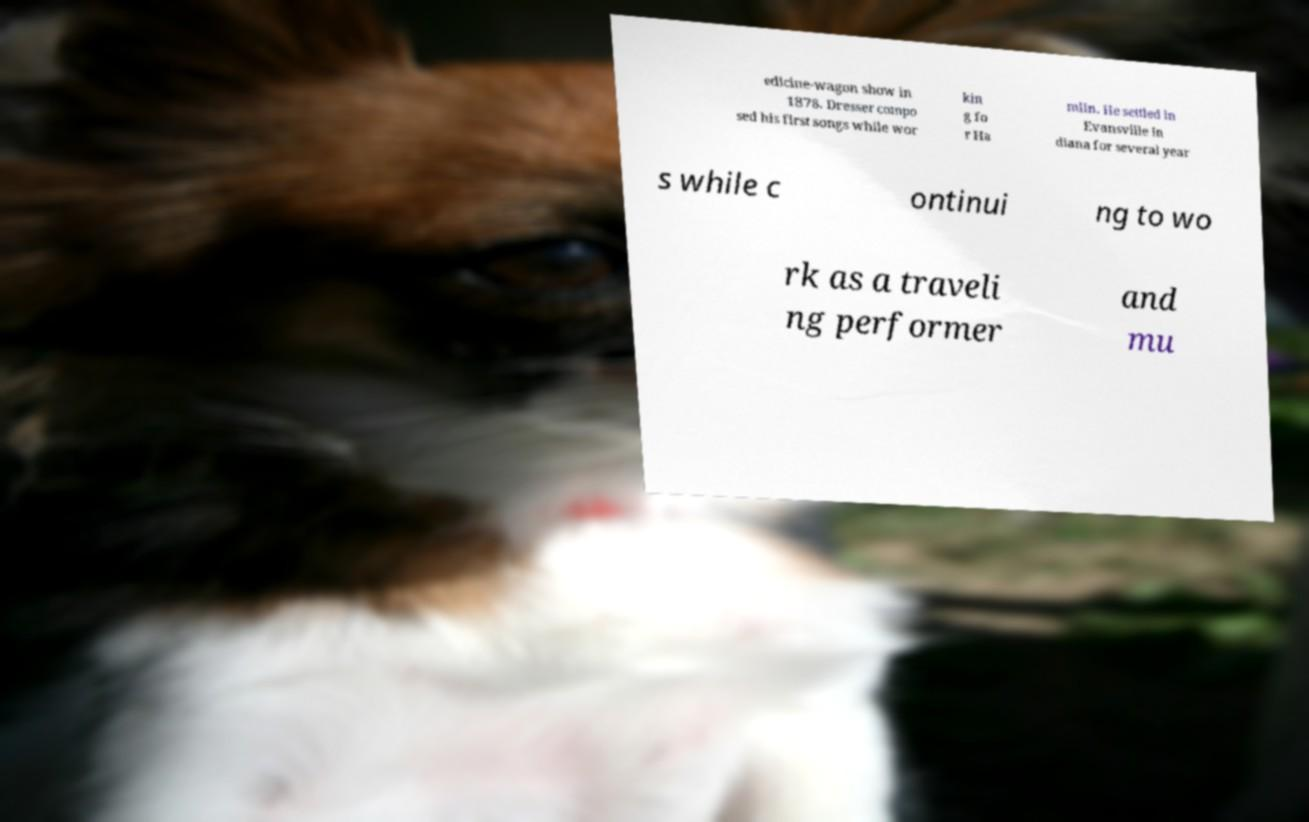Can you read and provide the text displayed in the image?This photo seems to have some interesting text. Can you extract and type it out for me? edicine-wagon show in 1878. Dresser compo sed his first songs while wor kin g fo r Ha mlin. He settled in Evansville In diana for several year s while c ontinui ng to wo rk as a traveli ng performer and mu 